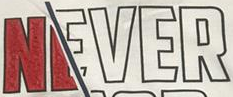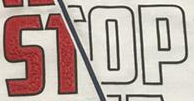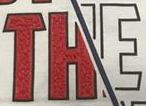What text appears in these images from left to right, separated by a semicolon? NEVER; STOP; THE 